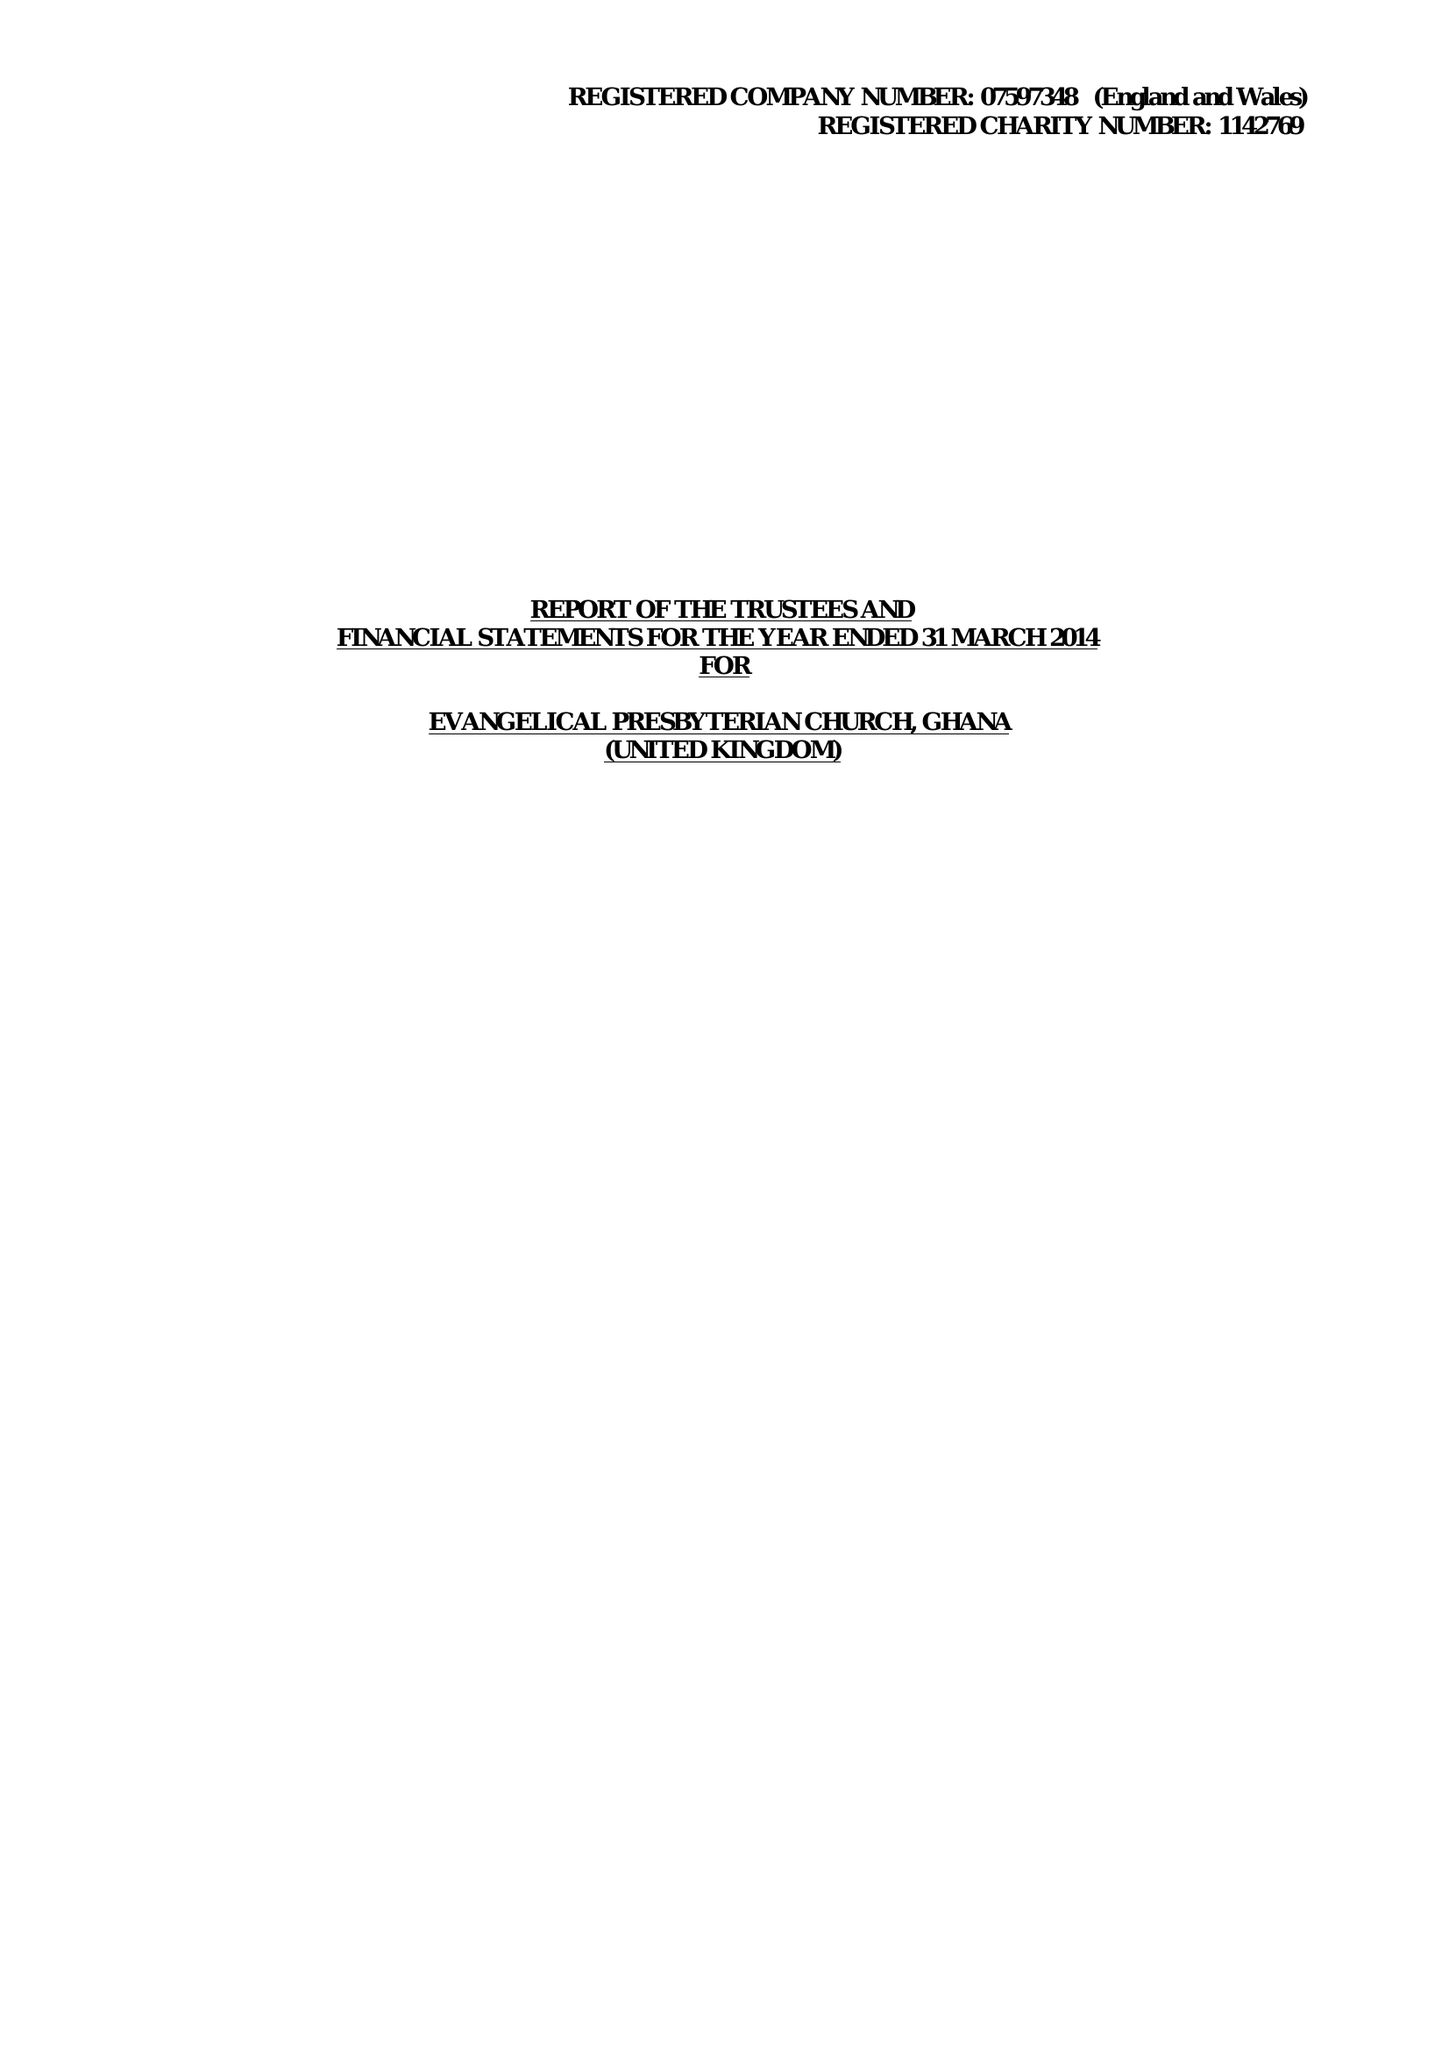What is the value for the spending_annually_in_british_pounds?
Answer the question using a single word or phrase. 62633.00 